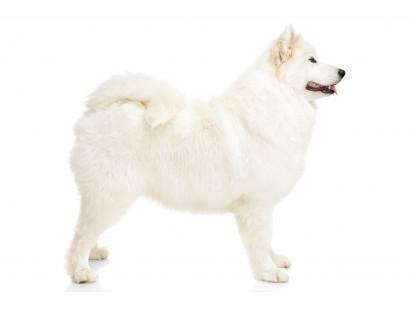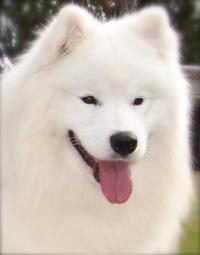The first image is the image on the left, the second image is the image on the right. For the images shown, is this caption "There is a lone dog with it's mouth open and tongue hanging out." true? Answer yes or no. Yes. 